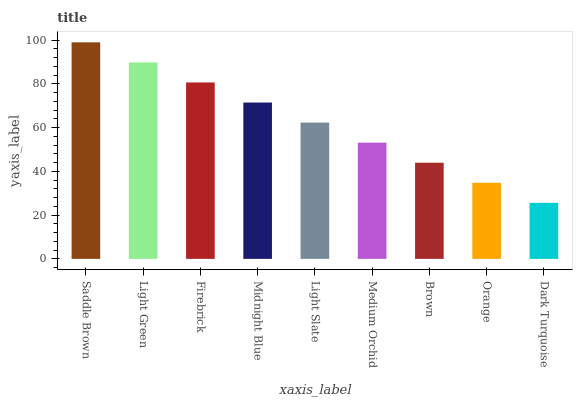Is Dark Turquoise the minimum?
Answer yes or no. Yes. Is Saddle Brown the maximum?
Answer yes or no. Yes. Is Light Green the minimum?
Answer yes or no. No. Is Light Green the maximum?
Answer yes or no. No. Is Saddle Brown greater than Light Green?
Answer yes or no. Yes. Is Light Green less than Saddle Brown?
Answer yes or no. Yes. Is Light Green greater than Saddle Brown?
Answer yes or no. No. Is Saddle Brown less than Light Green?
Answer yes or no. No. Is Light Slate the high median?
Answer yes or no. Yes. Is Light Slate the low median?
Answer yes or no. Yes. Is Midnight Blue the high median?
Answer yes or no. No. Is Orange the low median?
Answer yes or no. No. 